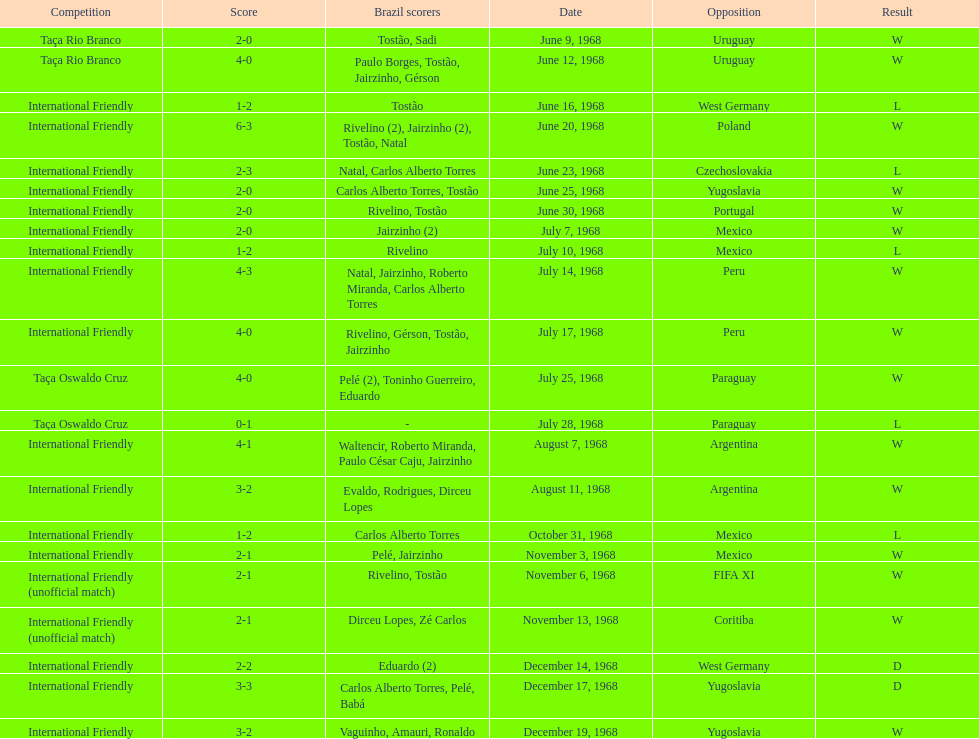How many times did brazil score during the game on november 6th? 2. Would you mind parsing the complete table? {'header': ['Competition', 'Score', 'Brazil scorers', 'Date', 'Opposition', 'Result'], 'rows': [['Taça Rio Branco', '2-0', 'Tostão, Sadi', 'June 9, 1968', 'Uruguay', 'W'], ['Taça Rio Branco', '4-0', 'Paulo Borges, Tostão, Jairzinho, Gérson', 'June 12, 1968', 'Uruguay', 'W'], ['International Friendly', '1-2', 'Tostão', 'June 16, 1968', 'West Germany', 'L'], ['International Friendly', '6-3', 'Rivelino (2), Jairzinho (2), Tostão, Natal', 'June 20, 1968', 'Poland', 'W'], ['International Friendly', '2-3', 'Natal, Carlos Alberto Torres', 'June 23, 1968', 'Czechoslovakia', 'L'], ['International Friendly', '2-0', 'Carlos Alberto Torres, Tostão', 'June 25, 1968', 'Yugoslavia', 'W'], ['International Friendly', '2-0', 'Rivelino, Tostão', 'June 30, 1968', 'Portugal', 'W'], ['International Friendly', '2-0', 'Jairzinho (2)', 'July 7, 1968', 'Mexico', 'W'], ['International Friendly', '1-2', 'Rivelino', 'July 10, 1968', 'Mexico', 'L'], ['International Friendly', '4-3', 'Natal, Jairzinho, Roberto Miranda, Carlos Alberto Torres', 'July 14, 1968', 'Peru', 'W'], ['International Friendly', '4-0', 'Rivelino, Gérson, Tostão, Jairzinho', 'July 17, 1968', 'Peru', 'W'], ['Taça Oswaldo Cruz', '4-0', 'Pelé (2), Toninho Guerreiro, Eduardo', 'July 25, 1968', 'Paraguay', 'W'], ['Taça Oswaldo Cruz', '0-1', '-', 'July 28, 1968', 'Paraguay', 'L'], ['International Friendly', '4-1', 'Waltencir, Roberto Miranda, Paulo César Caju, Jairzinho', 'August 7, 1968', 'Argentina', 'W'], ['International Friendly', '3-2', 'Evaldo, Rodrigues, Dirceu Lopes', 'August 11, 1968', 'Argentina', 'W'], ['International Friendly', '1-2', 'Carlos Alberto Torres', 'October 31, 1968', 'Mexico', 'L'], ['International Friendly', '2-1', 'Pelé, Jairzinho', 'November 3, 1968', 'Mexico', 'W'], ['International Friendly (unofficial match)', '2-1', 'Rivelino, Tostão', 'November 6, 1968', 'FIFA XI', 'W'], ['International Friendly (unofficial match)', '2-1', 'Dirceu Lopes, Zé Carlos', 'November 13, 1968', 'Coritiba', 'W'], ['International Friendly', '2-2', 'Eduardo (2)', 'December 14, 1968', 'West Germany', 'D'], ['International Friendly', '3-3', 'Carlos Alberto Torres, Pelé, Babá', 'December 17, 1968', 'Yugoslavia', 'D'], ['International Friendly', '3-2', 'Vaguinho, Amauri, Ronaldo', 'December 19, 1968', 'Yugoslavia', 'W']]} 